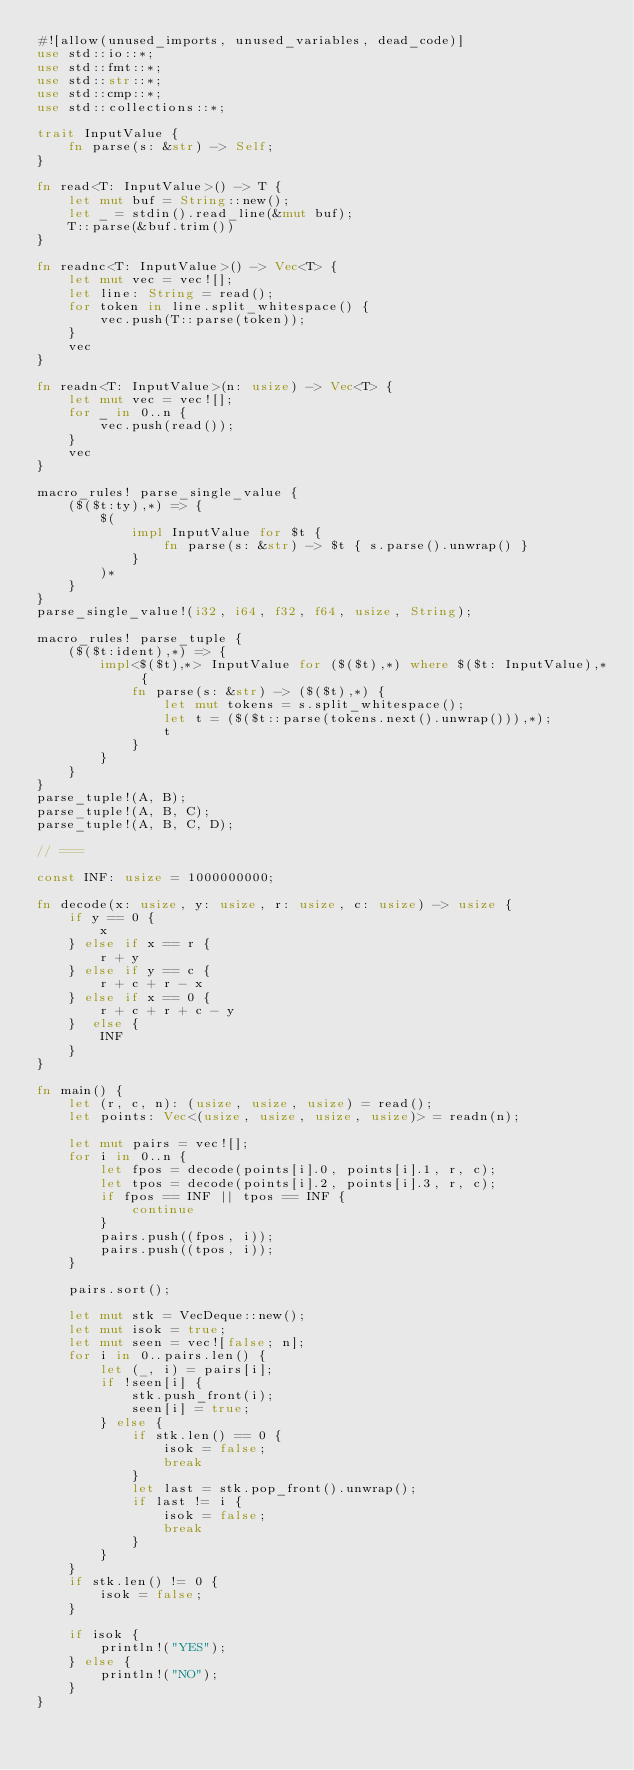Convert code to text. <code><loc_0><loc_0><loc_500><loc_500><_Rust_>#![allow(unused_imports, unused_variables, dead_code)]
use std::io::*;
use std::fmt::*;
use std::str::*;
use std::cmp::*;
use std::collections::*;

trait InputValue {
    fn parse(s: &str) -> Self;
}

fn read<T: InputValue>() -> T {
    let mut buf = String::new();
    let _ = stdin().read_line(&mut buf);
    T::parse(&buf.trim())
}

fn readnc<T: InputValue>() -> Vec<T> {
    let mut vec = vec![];
    let line: String = read();
    for token in line.split_whitespace() {
        vec.push(T::parse(token));
    }
    vec
}

fn readn<T: InputValue>(n: usize) -> Vec<T> {
    let mut vec = vec![];
    for _ in 0..n {
        vec.push(read());
    }
    vec
}

macro_rules! parse_single_value {
    ($($t:ty),*) => {
        $(
            impl InputValue for $t {
                fn parse(s: &str) -> $t { s.parse().unwrap() }
            }
        )*
	}
}
parse_single_value!(i32, i64, f32, f64, usize, String);

macro_rules! parse_tuple {
	($($t:ident),*) => {
		impl<$($t),*> InputValue for ($($t),*) where $($t: InputValue),* {
			fn parse(s: &str) -> ($($t),*) {
				let mut tokens = s.split_whitespace();
				let t = ($($t::parse(tokens.next().unwrap())),*);
				t
			}
		}
	}
}
parse_tuple!(A, B);
parse_tuple!(A, B, C);
parse_tuple!(A, B, C, D);

// ===

const INF: usize = 1000000000;

fn decode(x: usize, y: usize, r: usize, c: usize) -> usize {
    if y == 0 {
        x
    } else if x == r {
        r + y
    } else if y == c {
        r + c + r - x
    } else if x == 0 {
        r + c + r + c - y
    }  else {
        INF
    }
}

fn main() {
    let (r, c, n): (usize, usize, usize) = read();
    let points: Vec<(usize, usize, usize, usize)> = readn(n);

    let mut pairs = vec![];
    for i in 0..n {
        let fpos = decode(points[i].0, points[i].1, r, c);
        let tpos = decode(points[i].2, points[i].3, r, c);
        if fpos == INF || tpos == INF {
            continue
        }
        pairs.push((fpos, i));
        pairs.push((tpos, i));
    }

    pairs.sort();

    let mut stk = VecDeque::new();
    let mut isok = true;
    let mut seen = vec![false; n];
    for i in 0..pairs.len() {
        let (_, i) = pairs[i];
        if !seen[i] {
            stk.push_front(i);
            seen[i] = true;
        } else {
            if stk.len() == 0 {
                isok = false;
                break
            }
            let last = stk.pop_front().unwrap();
            if last != i {
                isok = false;
                break
            }
        }
    }
    if stk.len() != 0 {
        isok = false;
    }

    if isok {
        println!("YES");
    } else {
        println!("NO");
    }
}</code> 